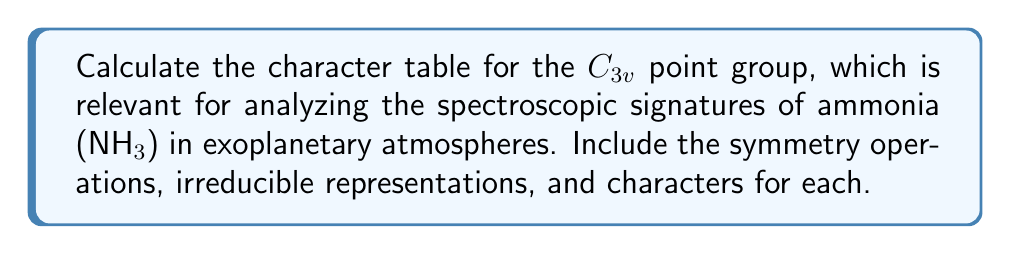Can you solve this math problem? To calculate the character table for the $C_{3v}$ point group, we follow these steps:

1. Identify symmetry operations:
   - E: identity
   - 2C₃: two 120° rotations around the principal axis
   - 3σᵥ: three vertical mirror planes

2. Determine the number of irreducible representations:
   The number of irreducible representations is equal to the number of classes of symmetry operations. For $C_{3v}$, we have 3 classes: {E}, {2C₃}, and {3σᵥ}.

3. Calculate the dimensions of irreducible representations:
   Using the formula: $\sum_i n_i^2 = h$ (where $n_i$ are dimensions and $h$ is the order of the group)
   For $C_{3v}$, $h = 6$, so we have: $1^2 + 1^2 + 2^2 = 6$
   This gives us two 1-dimensional representations (A₁ and A₂) and one 2-dimensional representation (E).

4. Determine characters for each representation:
   a) A₁ (totally symmetric): all characters are 1
   b) A₂: characters are 1 for E and C₃, -1 for σᵥ
   c) E: use orthogonality relations and the fact that the sum of squares of characters equals the order of the group

5. Construct the character table:

   $$
   \begin{array}{c|ccc}
   C_{3v} & E & 2C_3 & 3\sigma_v \\
   \hline
   A_1 & 1 & 1 & 1 \\
   A_2 & 1 & 1 & -1 \\
   E & 2 & -1 & 0
   \end{array}
   $$

6. Add basis functions for each irreducible representation:
   - A₁: z, x² + y², z²
   - A₂: R_z
   - E: (x, y), (R_x, R_y), (x² - y², xy)

This character table is crucial for analyzing the vibrational modes and rotational structure of ammonia in exoplanetary atmospheres, as it helps predict the selection rules and intensities of spectroscopic transitions.
Answer: $$
\begin{array}{c|ccc|c}
C_{3v} & E & 2C_3 & 3\sigma_v & \text{Basis} \\
\hline
A_1 & 1 & 1 & 1 & z, x^2 + y^2, z^2 \\
A_2 & 1 & 1 & -1 & R_z \\
E & 2 & -1 & 0 & (x, y), (R_x, R_y), (x^2 - y^2, xy)
\end{array}
$$ 